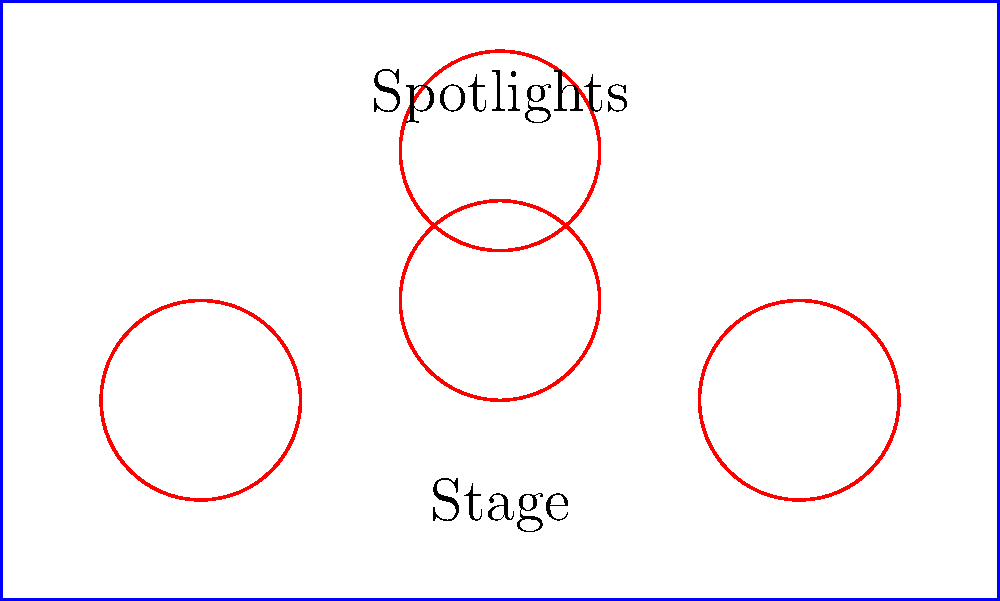As a TV drama composer, you're tasked with arranging circular spotlights on a rectangular stage for a new award ceremony. The stage measures 10 meters wide and 6 meters deep. If each spotlight has a radius of 1 meter, what is the maximum number of spotlights that can be placed on the stage without overlapping, while ensuring full coverage of the stage area? To solve this problem, we need to follow these steps:

1. Calculate the area of the stage:
   Area of stage = $10 \text{ m} \times 6 \text{ m} = 60 \text{ m}^2$

2. Calculate the area of each spotlight:
   Area of spotlight = $\pi r^2 = \pi \times (1 \text{ m})^2 = \pi \text{ m}^2$

3. To ensure full coverage, we need to consider the square that circumscribes each circular spotlight. The side length of this square would be the diameter of the spotlight:
   Side of square = $2r = 2 \times 1 \text{ m} = 2 \text{ m}$

4. Calculate the area of the square:
   Area of square = $2 \text{ m} \times 2 \text{ m} = 4 \text{ m}^2$

5. Find the number of squares that can fit in the stage area:
   Number of squares = $\frac{\text{Area of stage}}{\text{Area of square}} = \frac{60 \text{ m}^2}{4 \text{ m}^2} = 15$

Therefore, the maximum number of non-overlapping spotlights that can be placed on the stage while ensuring full coverage is 15.
Answer: 15 spotlights 